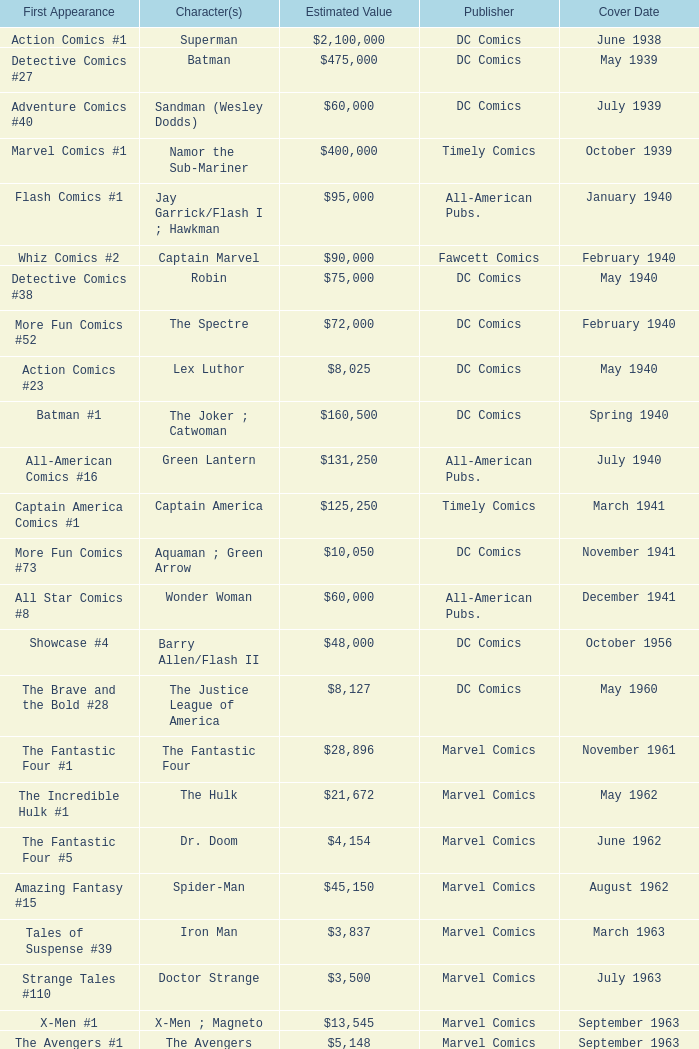Who publishes Wolverine? Marvel Comics. 